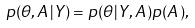<formula> <loc_0><loc_0><loc_500><loc_500>p ( \theta , A | Y ) = p ( \theta | Y , A ) p ( A ) ,</formula> 